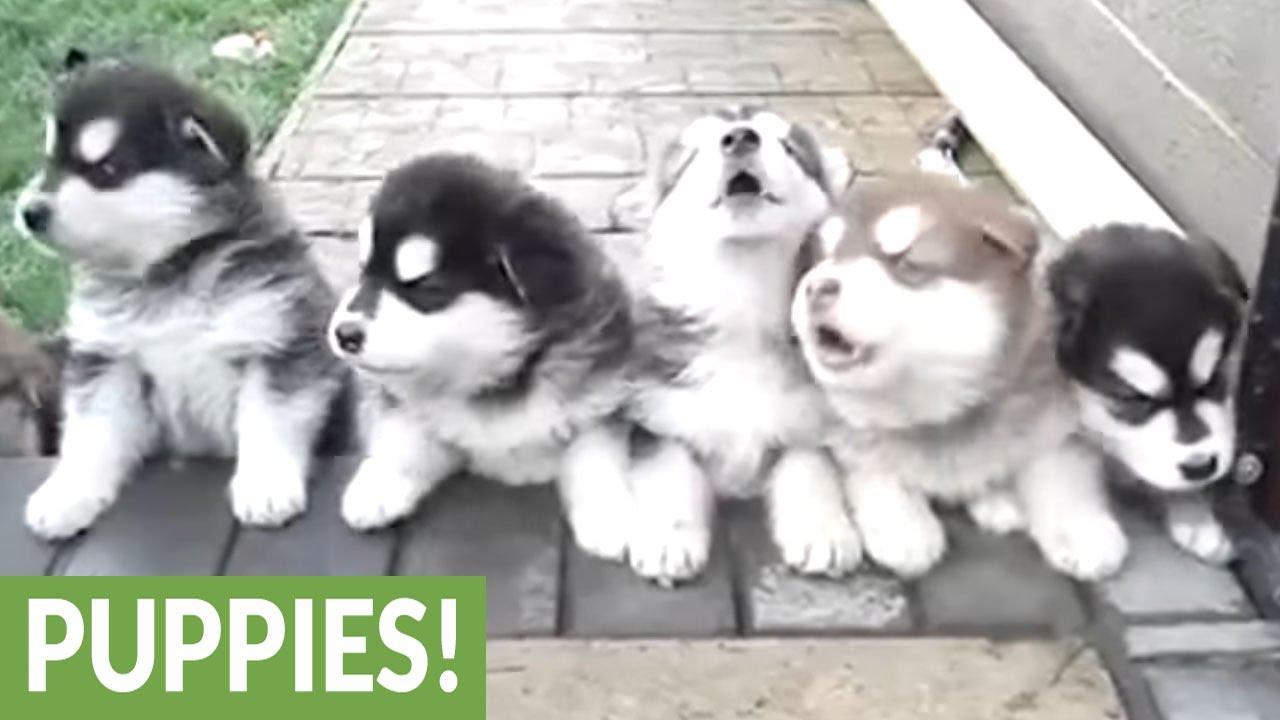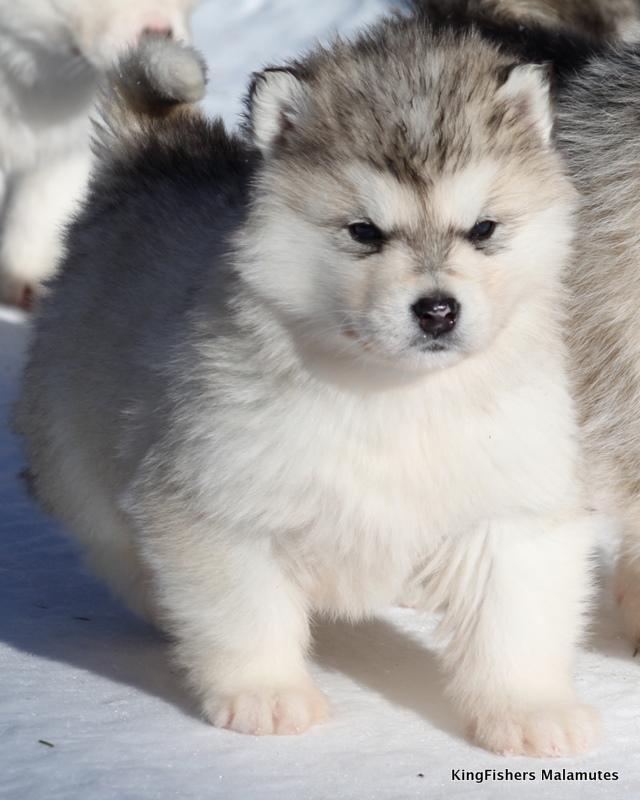The first image is the image on the left, the second image is the image on the right. For the images displayed, is the sentence "One of the two malamutes has its tongue sticking out, while the other is just staring at the camera." factually correct? Answer yes or no. No. The first image is the image on the left, the second image is the image on the right. Evaluate the accuracy of this statement regarding the images: "The puppy on the left has its tongue visible.". Is it true? Answer yes or no. No. 